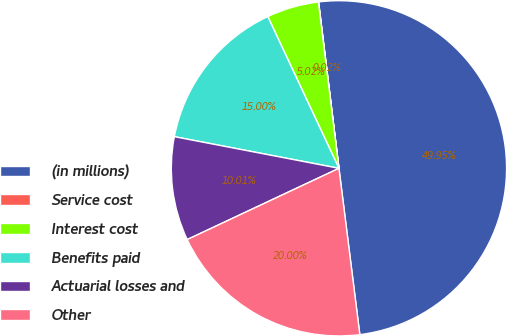Convert chart. <chart><loc_0><loc_0><loc_500><loc_500><pie_chart><fcel>(in millions)<fcel>Service cost<fcel>Interest cost<fcel>Benefits paid<fcel>Actuarial losses and<fcel>Other<nl><fcel>49.95%<fcel>0.02%<fcel>5.02%<fcel>15.0%<fcel>10.01%<fcel>20.0%<nl></chart> 